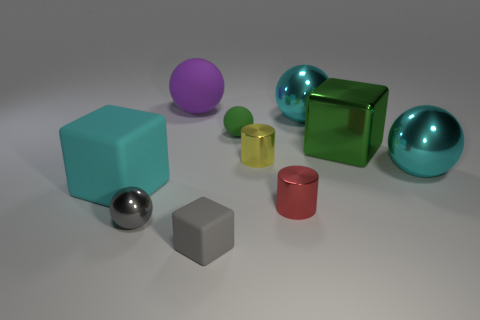There is a tiny sphere behind the cylinder to the left of the small red metallic thing; what is its material?
Your answer should be compact. Rubber. What shape is the cyan thing that is made of the same material as the tiny cube?
Provide a succinct answer. Cube. What number of large things are either gray shiny cylinders or yellow objects?
Your answer should be very brief. 0. Are there any gray matte cubes behind the big metal object in front of the tiny yellow metal thing?
Offer a terse response. No. Are any small gray matte blocks visible?
Your answer should be compact. Yes. What color is the big shiny object that is behind the tiny matte object behind the small red thing?
Your answer should be compact. Cyan. What material is the other object that is the same shape as the yellow metal thing?
Your answer should be very brief. Metal. How many red metallic things are the same size as the yellow cylinder?
Your answer should be compact. 1. There is another sphere that is the same material as the purple sphere; what size is it?
Provide a succinct answer. Small. What number of other tiny objects have the same shape as the tiny green matte thing?
Offer a terse response. 1. 